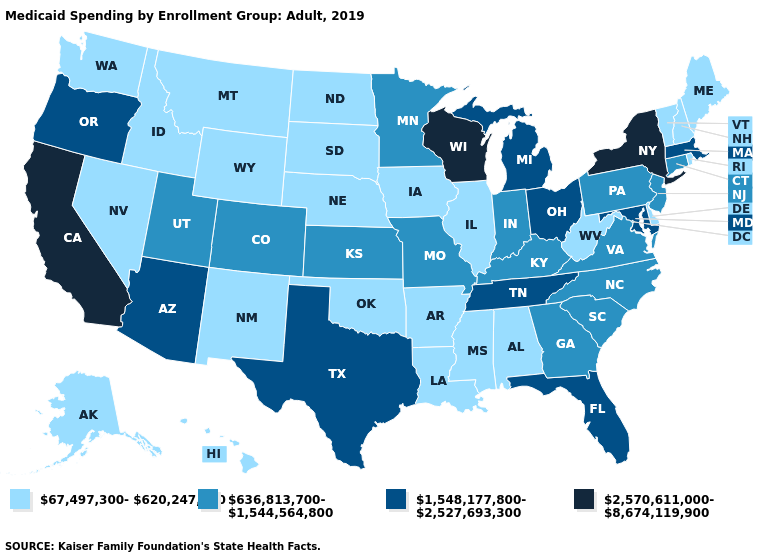Name the states that have a value in the range 636,813,700-1,544,564,800?
Short answer required. Colorado, Connecticut, Georgia, Indiana, Kansas, Kentucky, Minnesota, Missouri, New Jersey, North Carolina, Pennsylvania, South Carolina, Utah, Virginia. How many symbols are there in the legend?
Short answer required. 4. Does Michigan have the lowest value in the USA?
Quick response, please. No. Among the states that border North Carolina , which have the lowest value?
Short answer required. Georgia, South Carolina, Virginia. Does Utah have a lower value than South Carolina?
Concise answer only. No. What is the lowest value in states that border North Carolina?
Keep it brief. 636,813,700-1,544,564,800. What is the value of West Virginia?
Concise answer only. 67,497,300-620,247,700. Name the states that have a value in the range 1,548,177,800-2,527,693,300?
Answer briefly. Arizona, Florida, Maryland, Massachusetts, Michigan, Ohio, Oregon, Tennessee, Texas. What is the lowest value in states that border Nevada?
Answer briefly. 67,497,300-620,247,700. Which states have the lowest value in the Northeast?
Be succinct. Maine, New Hampshire, Rhode Island, Vermont. What is the value of Utah?
Give a very brief answer. 636,813,700-1,544,564,800. What is the value of Nevada?
Answer briefly. 67,497,300-620,247,700. How many symbols are there in the legend?
Write a very short answer. 4. Name the states that have a value in the range 67,497,300-620,247,700?
Write a very short answer. Alabama, Alaska, Arkansas, Delaware, Hawaii, Idaho, Illinois, Iowa, Louisiana, Maine, Mississippi, Montana, Nebraska, Nevada, New Hampshire, New Mexico, North Dakota, Oklahoma, Rhode Island, South Dakota, Vermont, Washington, West Virginia, Wyoming. 